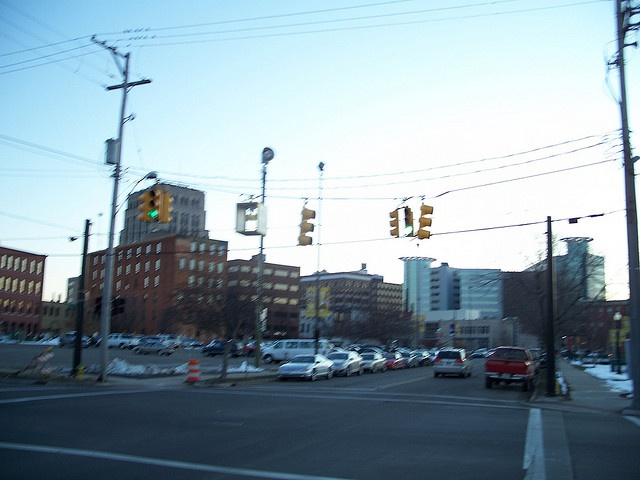Describe the objects in this image and their specific colors. I can see truck in gray, black, and blue tones, traffic light in gray and olive tones, car in gray, black, and blue tones, truck in gray, blue, and black tones, and car in gray, black, blue, and darkblue tones in this image. 